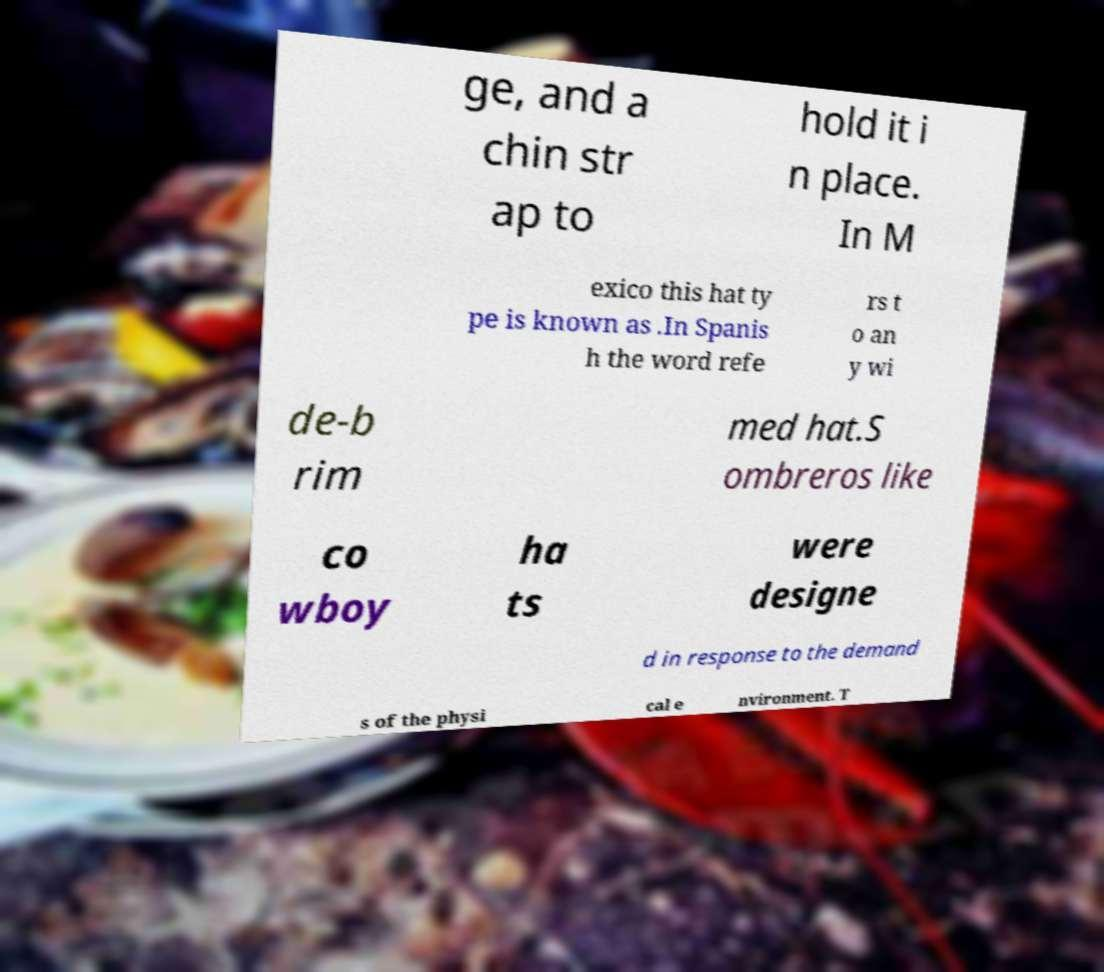I need the written content from this picture converted into text. Can you do that? ge, and a chin str ap to hold it i n place. In M exico this hat ty pe is known as .In Spanis h the word refe rs t o an y wi de-b rim med hat.S ombreros like co wboy ha ts were designe d in response to the demand s of the physi cal e nvironment. T 